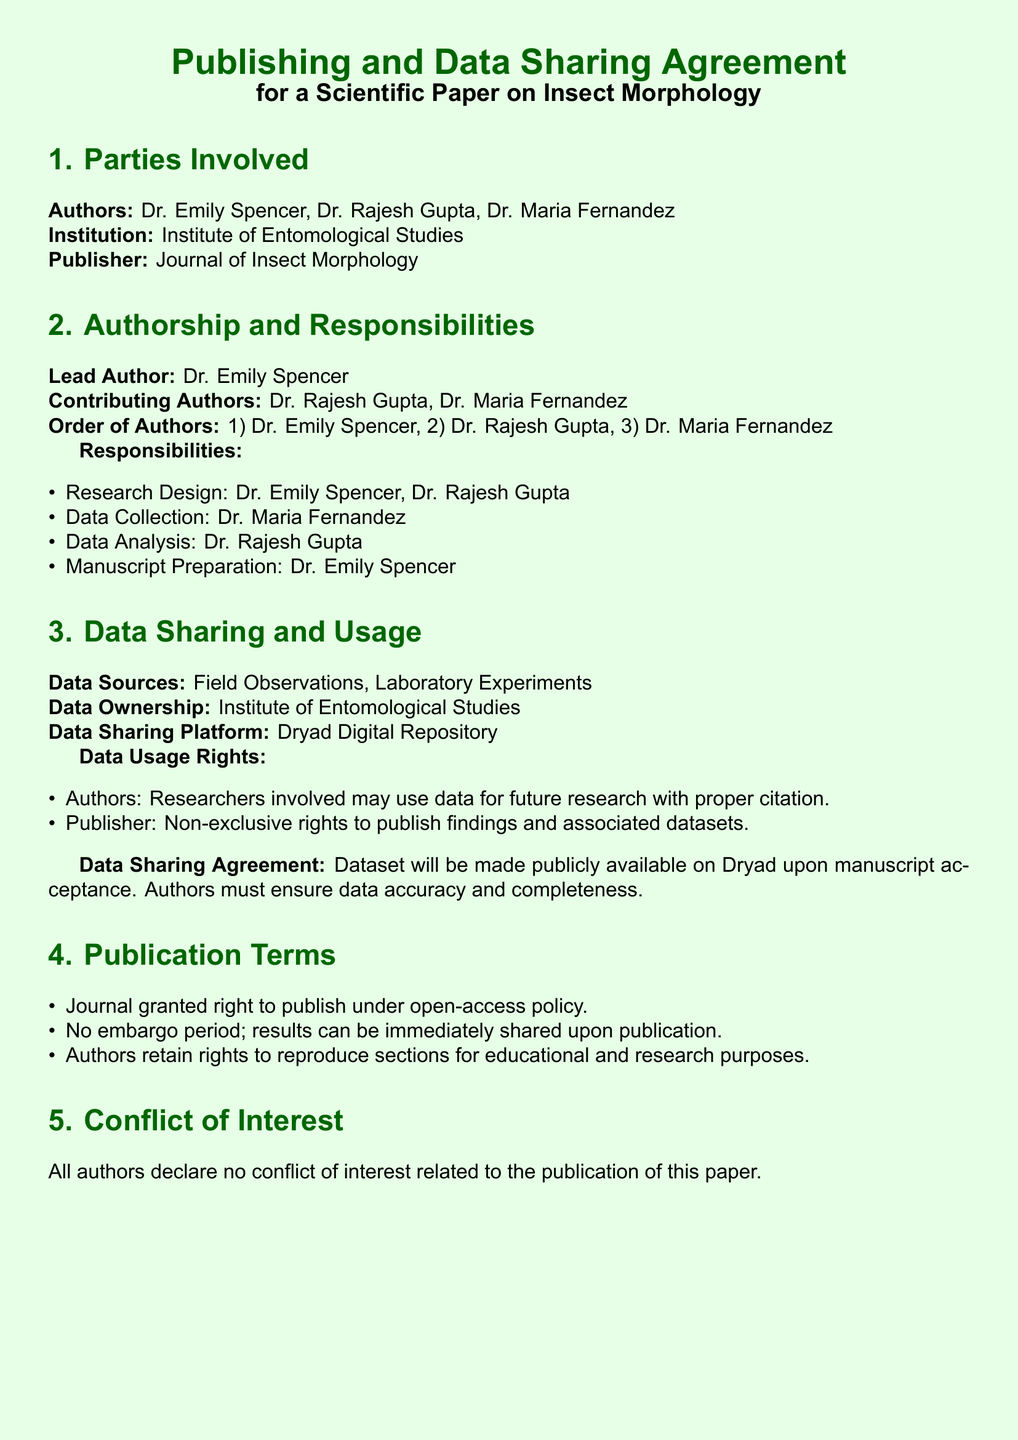What is the lead author's name? The lead author's name is mentioned in the authors' section of the document.
Answer: Dr. Emily Spencer Who are the contributing authors? The contributing authors are listed in the authors' section, specifically under the contributing authors label.
Answer: Dr. Rajesh Gupta, Dr. Maria Fernandez What is the data sharing platform mentioned in the document? The data sharing platform is detailed in the data sharing and usage section of the document.
Answer: Dryad Digital Repository What responsibilities does Dr. Maria Fernandez have? Dr. Maria Fernandez's responsibilities are outlined in the responsibilities itemized section of the document.
Answer: Data Collection How many authors are listed in the document? The document specifies the number of authors in the parties involved section.
Answer: Three What rights do authors have regarding data usage? The rights for authors are specified under the data usage rights section, detailing how they can utilize data.
Answer: Use data for future research with proper citation Is there an embargo period for publication terms? The publication terms section explicitly states whether there is an embargo period.
Answer: No What does the conflict of interest section declare? The declaration in the conflict of interest section provides clarity about the authors' stance on conflicts related to publication.
Answer: No conflict of interest What will occur to the dataset upon manuscript acceptance? The document indicates what happens to the dataset in the data sharing agreement section.
Answer: Publicly available on Dryad 